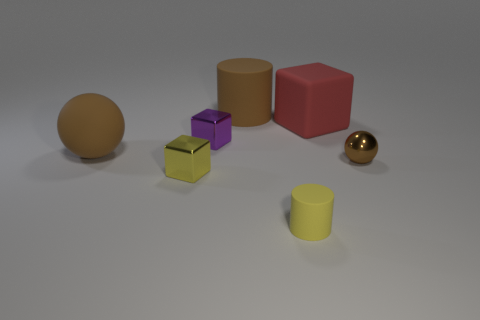How many shiny cubes are there? There appears to be just one shiny cube among the objects, distinguishable by its reflective surface and geometric shape. 